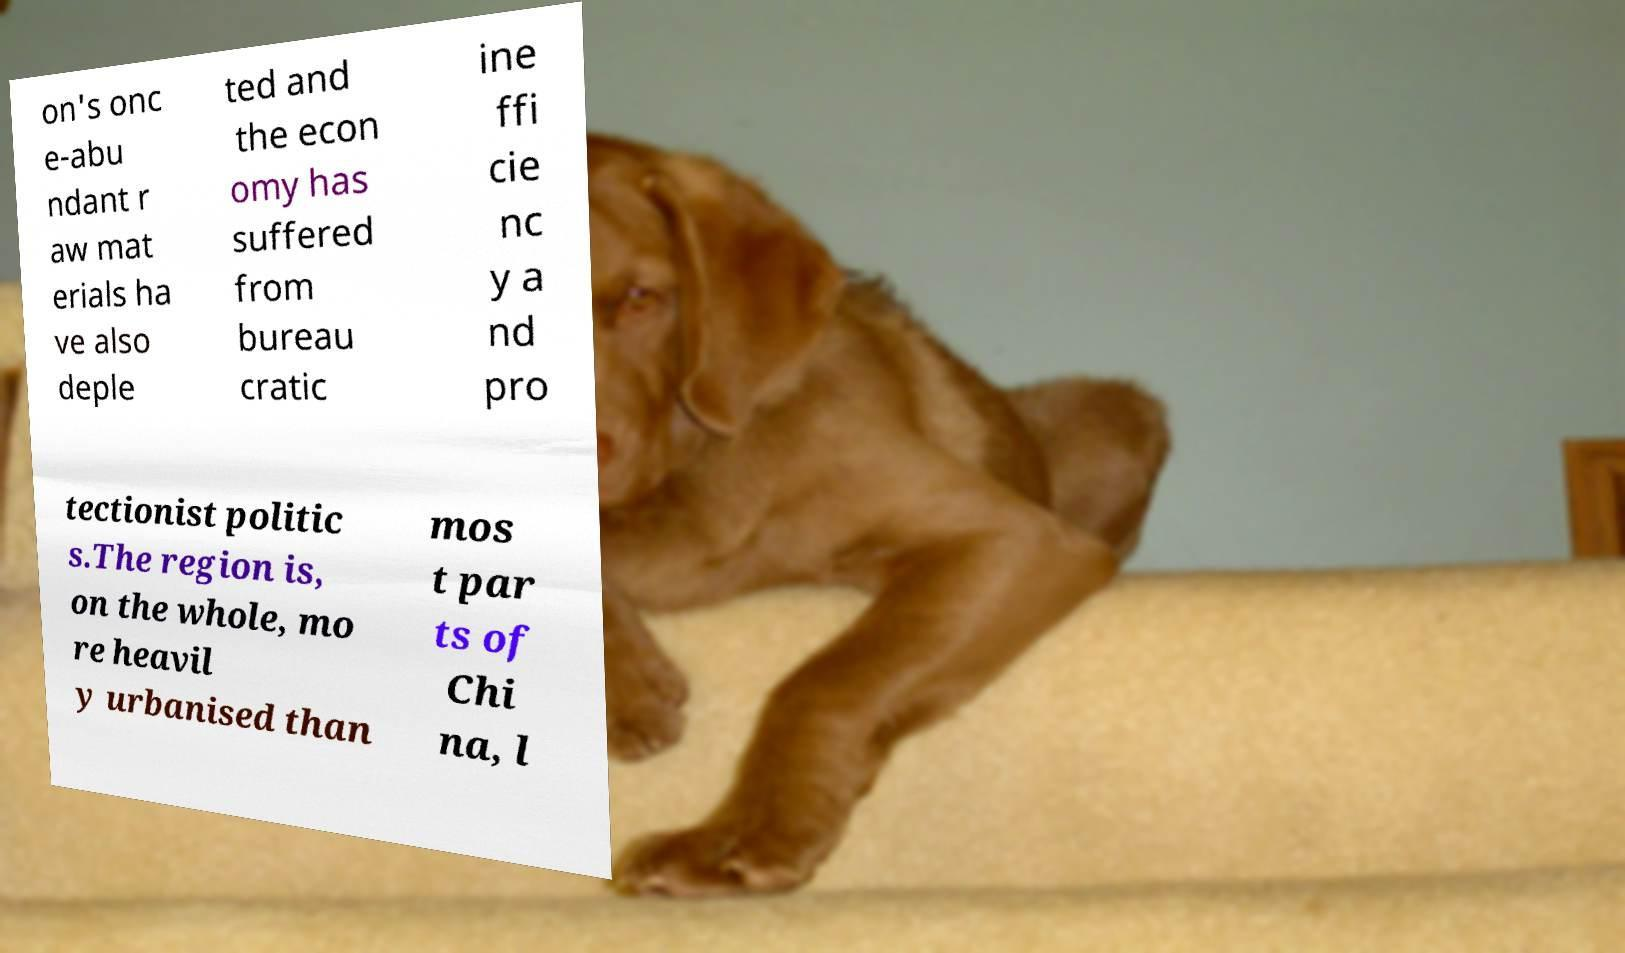There's text embedded in this image that I need extracted. Can you transcribe it verbatim? on's onc e-abu ndant r aw mat erials ha ve also deple ted and the econ omy has suffered from bureau cratic ine ffi cie nc y a nd pro tectionist politic s.The region is, on the whole, mo re heavil y urbanised than mos t par ts of Chi na, l 